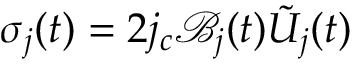Convert formula to latex. <formula><loc_0><loc_0><loc_500><loc_500>\sigma _ { j } ( t ) = 2 j _ { c } \mathcal { B } _ { j } ( t ) \tilde { U } _ { j } ( t )</formula> 